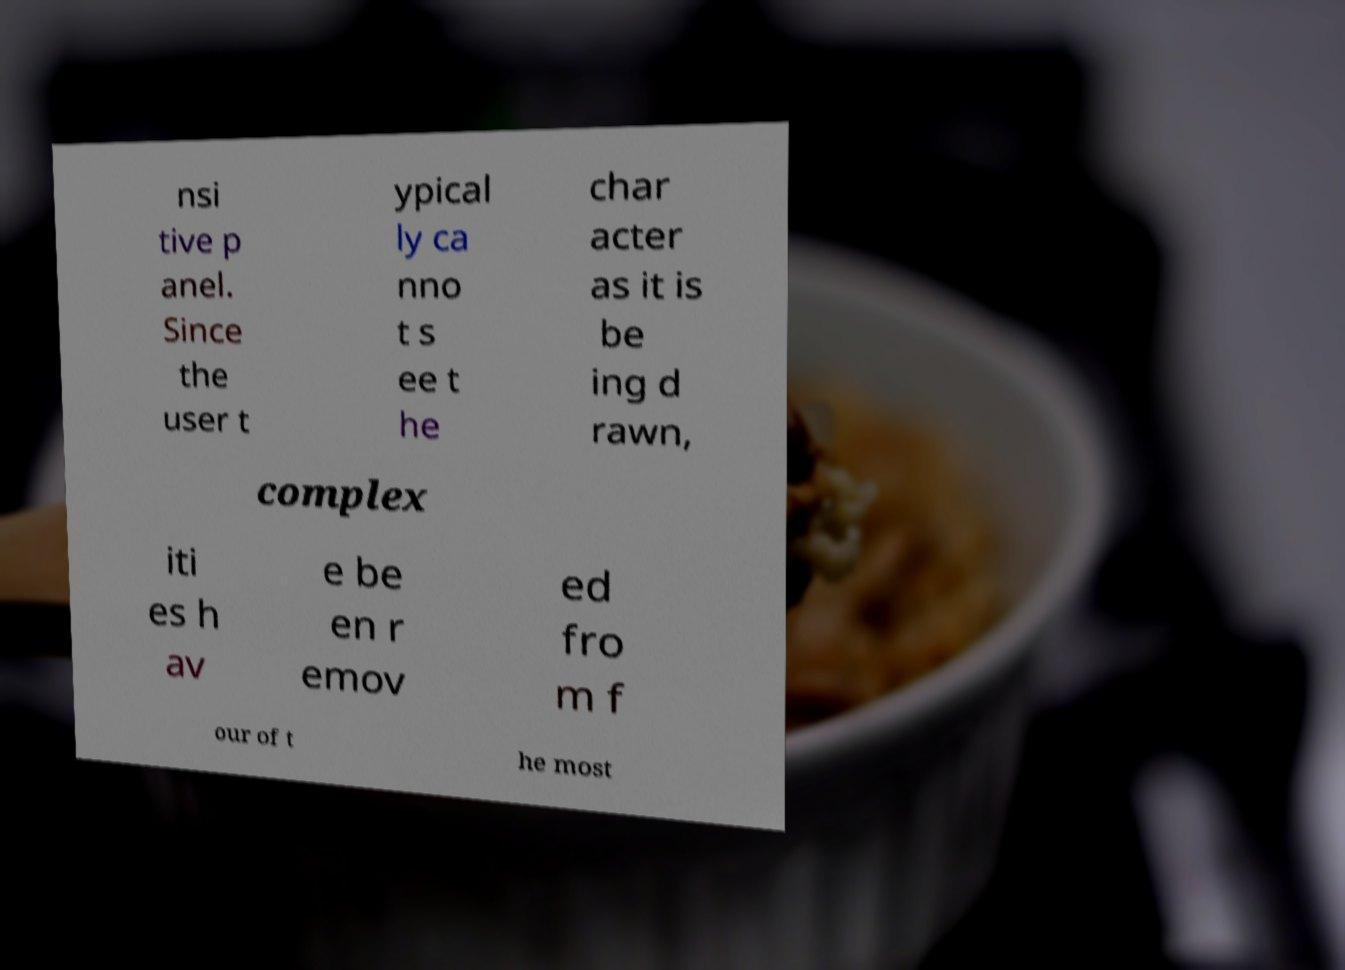For documentation purposes, I need the text within this image transcribed. Could you provide that? nsi tive p anel. Since the user t ypical ly ca nno t s ee t he char acter as it is be ing d rawn, complex iti es h av e be en r emov ed fro m f our of t he most 